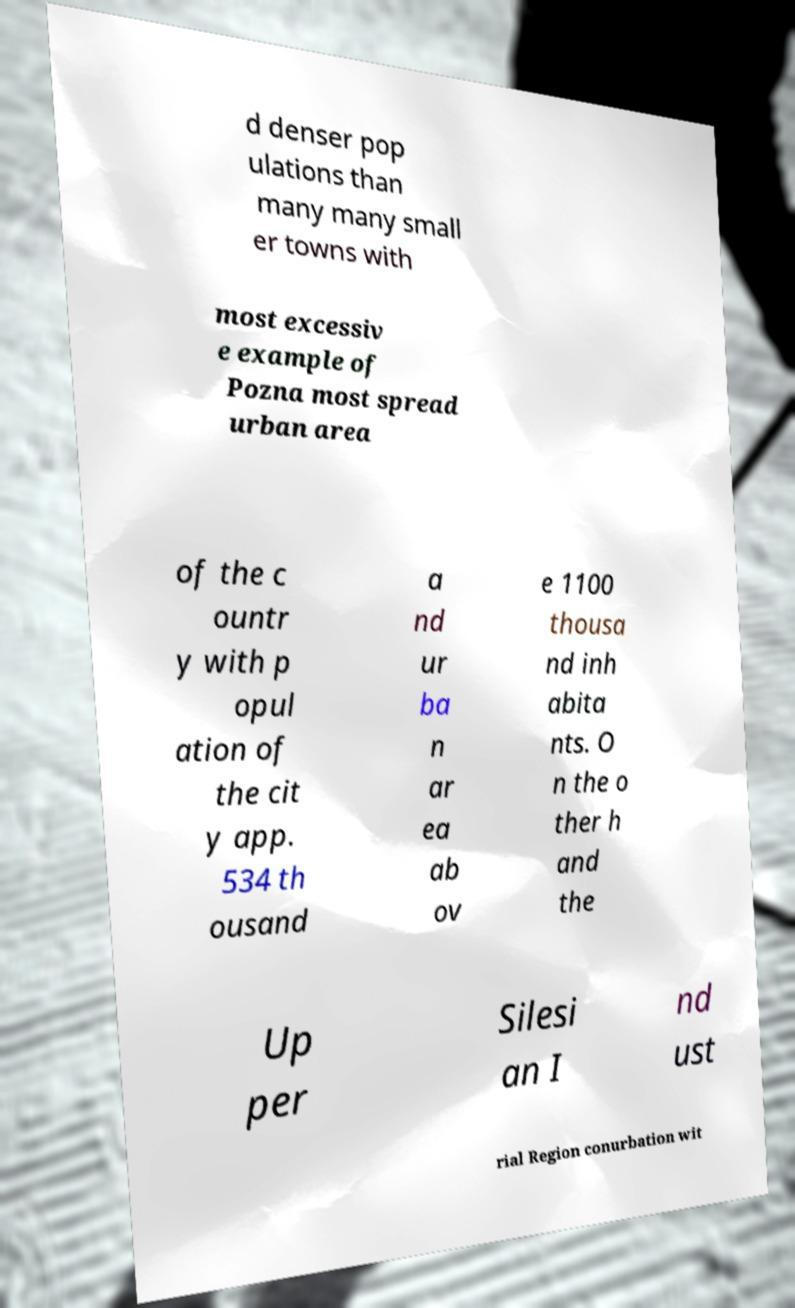There's text embedded in this image that I need extracted. Can you transcribe it verbatim? d denser pop ulations than many many small er towns with most excessiv e example of Pozna most spread urban area of the c ountr y with p opul ation of the cit y app. 534 th ousand a nd ur ba n ar ea ab ov e 1100 thousa nd inh abita nts. O n the o ther h and the Up per Silesi an I nd ust rial Region conurbation wit 